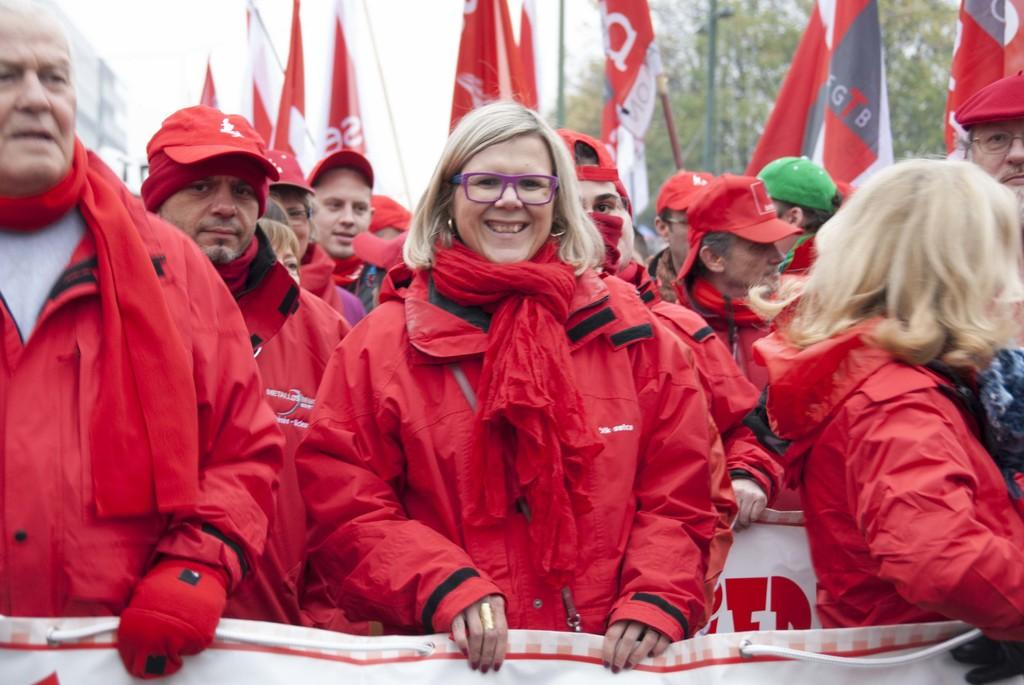What are the people in the image doing? There are people standing in the image, some of whom are holding a banner and flags. What objects are the people holding in the image? Some people are holding a banner and flags in the image. What can be seen in the background of the image? There are trees and buildings in the background of the image. What type of plantation can be seen in the image? There is no plantation present in the image. Can you tell me how many zebras are visible in the image? There are no zebras present in the image. 